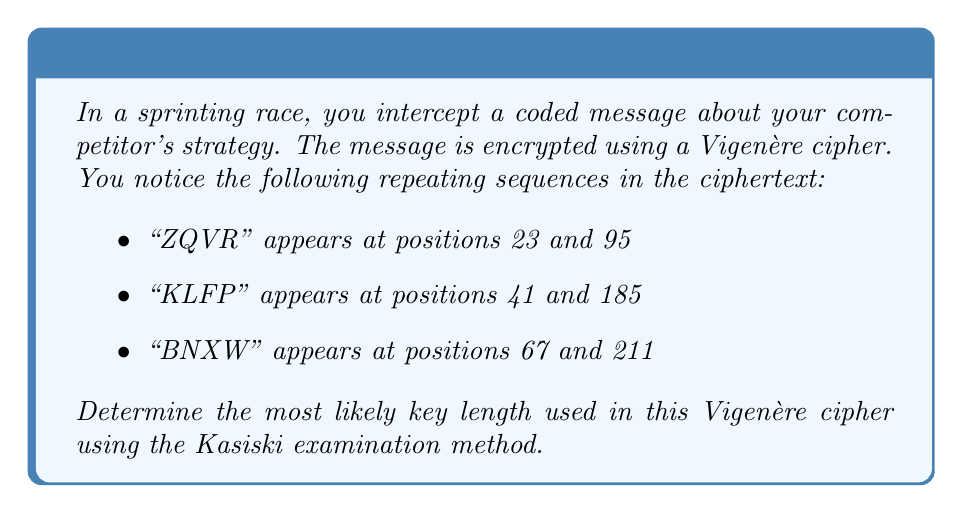Provide a solution to this math problem. To determine the key length using the Kasiski examination, we follow these steps:

1. Identify the distances between repeated sequences:
   - For "ZQVR": 95 - 23 = 72
   - For "KLFP": 185 - 41 = 144
   - For "BNXW": 211 - 67 = 144

2. Find the greatest common divisor (GCD) of these distances:
   $GCD(72, 144, 144)$

3. To calculate the GCD, we use the Euclidean algorithm:
   $144 = 2 \times 72 + 0$
   
   The GCD is 72.

4. Factor 72 into its prime factors:
   $72 = 2^3 \times 3^2$

5. The most likely key length is the largest factor of 72 that makes sense for a Vigenère cipher key. In this case, it's 12 $(2^2 \times 3)$.

Therefore, the most likely key length is 12 characters.
Answer: 12 